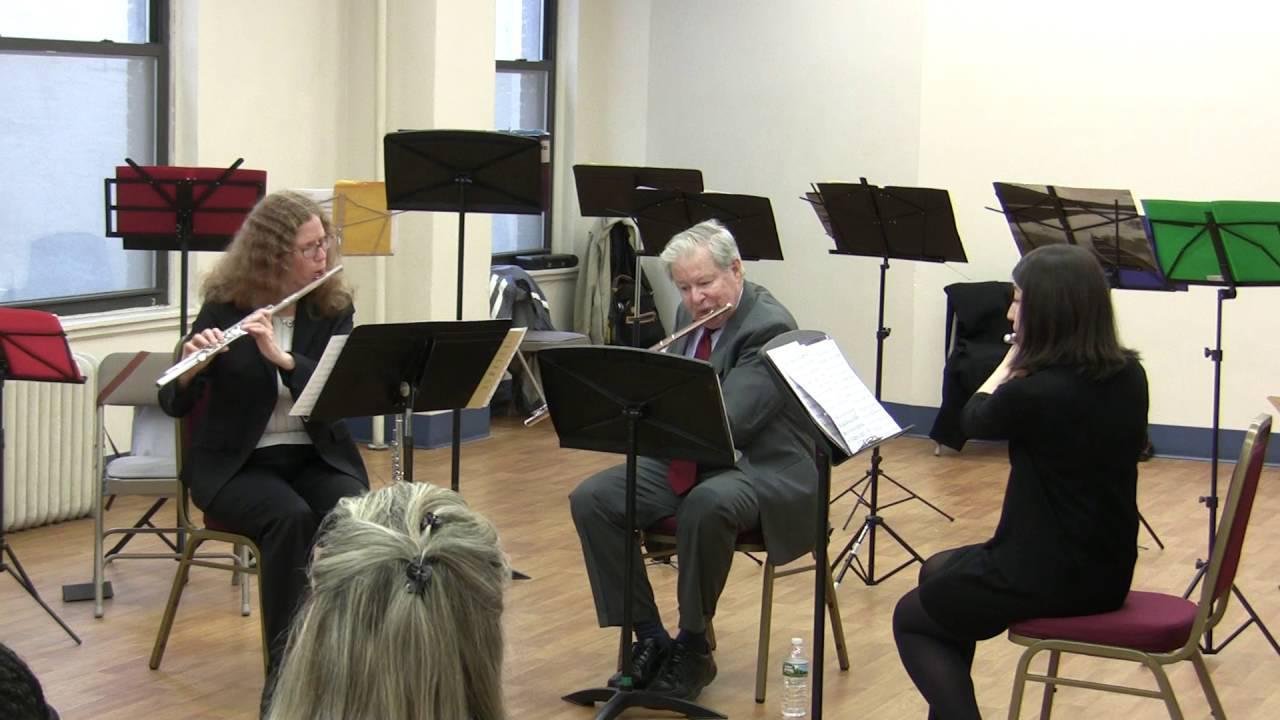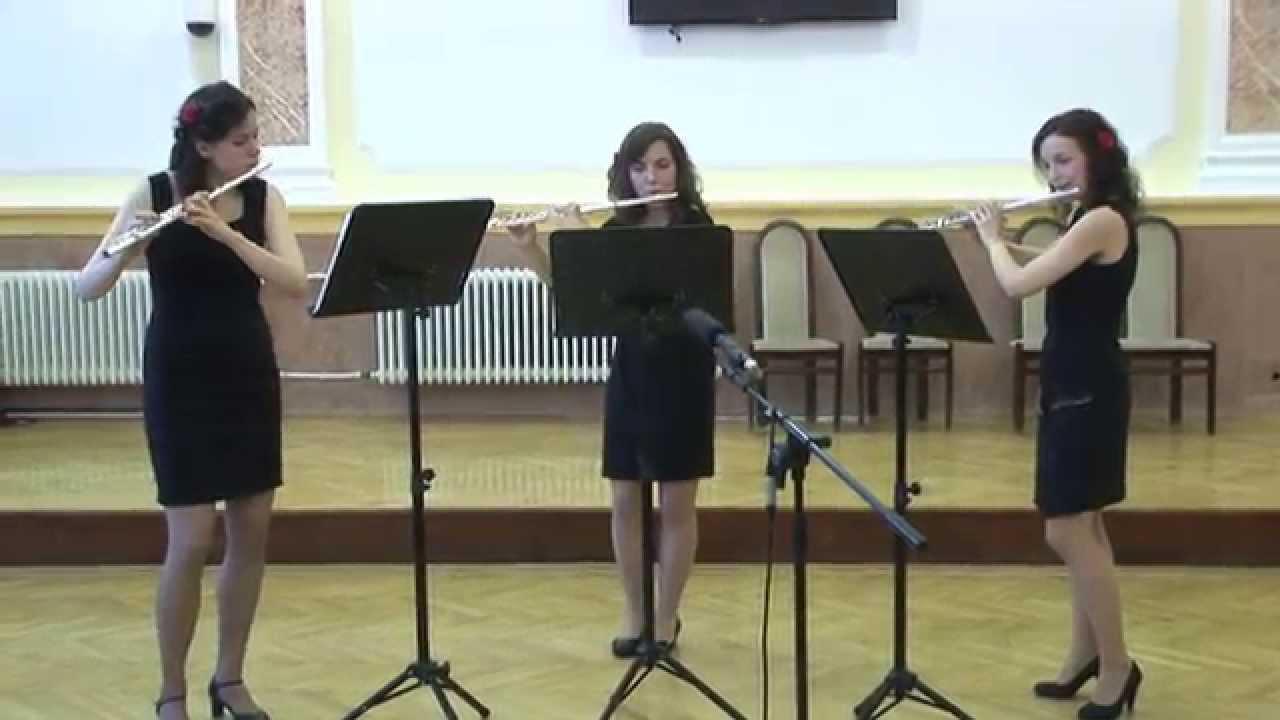The first image is the image on the left, the second image is the image on the right. Given the left and right images, does the statement "There are three women in black dresses  looking at sheet music while playing the flute" hold true? Answer yes or no. Yes. The first image is the image on the left, the second image is the image on the right. Evaluate the accuracy of this statement regarding the images: "There are six flutists standing.". Is it true? Answer yes or no. No. 